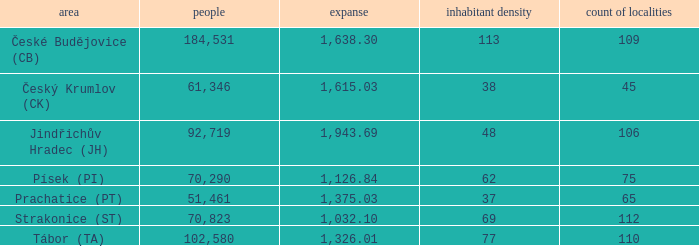How many settlements are in český krumlov (ck) with a population density higher than 38? None. 